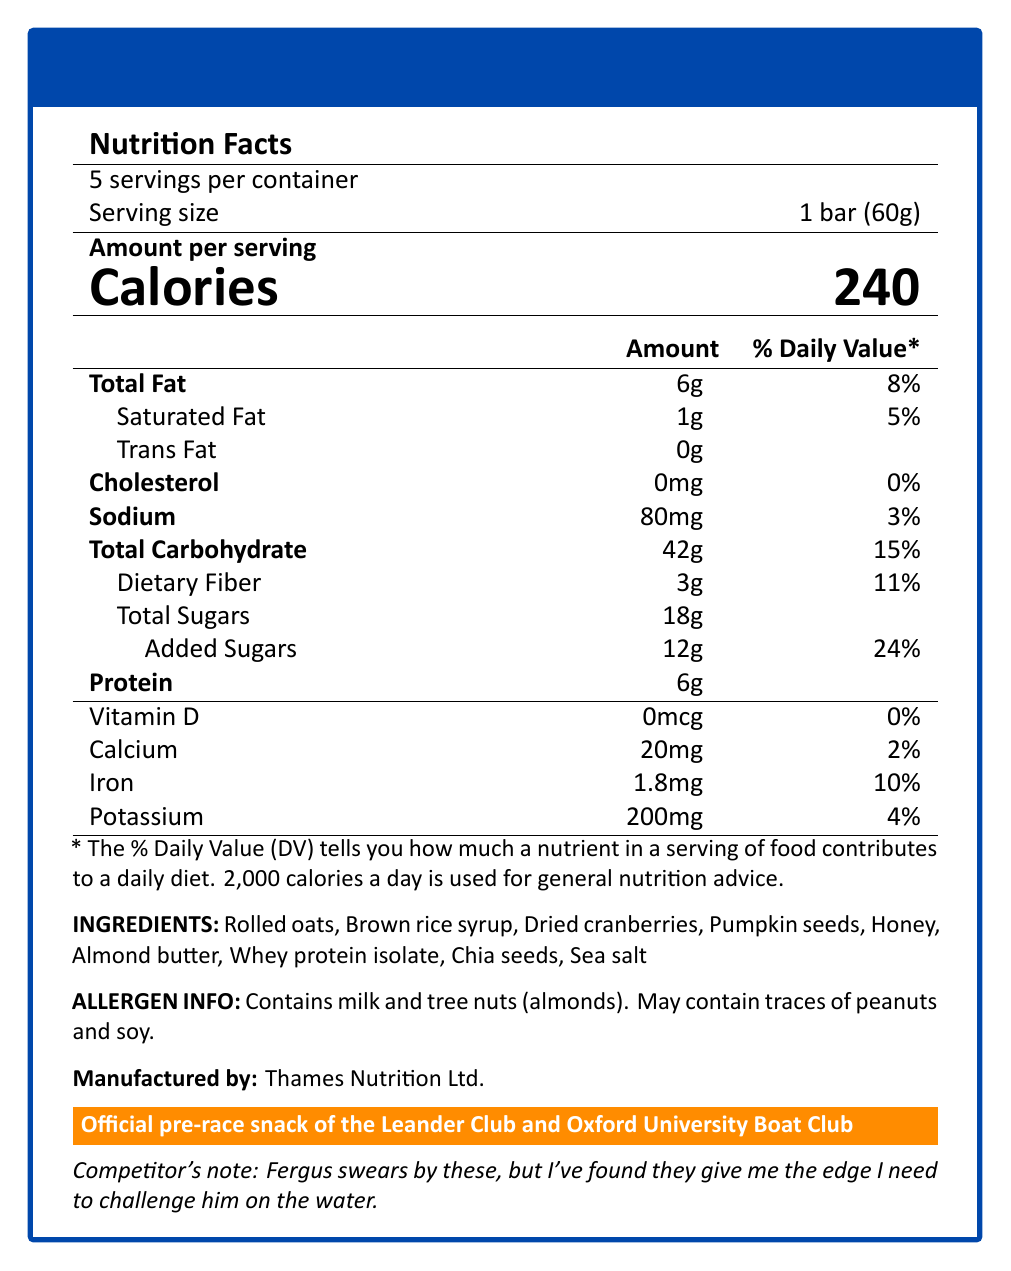what is the serving size? The serving size is clearly stated as "1 bar (60g)" under "Serving size."
Answer: 1 bar (60g) how many servings are there per container? The document mentions that there are 5 servings per container.
Answer: 5 how many total calories are there in one bar? Under "Amount per serving," it lists "Calories" with the value "240."
Answer: 240 what is the primary ingredient in the Power Oar Energy Bar? The ingredients list starts with "Rolled oats."
Answer: Rolled oats what is the total fat content in one serving? Under "Total Fat," the document specifies "6g."
Answer: 6g how much protein does the energy bar contain? The protein content is directly listed as "6g."
Answer: 6g how many grams of added sugars are there per serving? A. 10g B. 12g C. 18g D. 24g The document indicates "Added Sugars" with a value of "12g."
Answer: B. 12g which of the following is a potential allergen in this product? A. Soy B. Peanuts C. Almonds D. All of the above The allergen information mentions it contains milk and tree nuts (almonds) and may contain traces of peanuts and soy. Therefore, D is the correct option.
Answer: D. All of the above are there any trans fats in the Power Oar Energy Bar? The document lists "0g" of trans fat, indicating there are none.
Answer: No does this energy bar contain any Vitamin D? The nutrition information states "0mcg" for Vitamin D, which means it does not contain any Vitamin D.
Answer: No summarize the main purpose of this document. The document's main purpose is to inform consumers about the nutritional characteristics, ingredients, and endorsements of the Power Oar Energy Bar.
Answer: The document provides nutritional information, ingredients, allergen info, and product endorsement for the "Power Oar Energy Bar," a high-carb energy bar designed for British rowers and backed by notable rowing clubs. who manufactures this energy bar? The document specifies that the manufacturer is "Thames Nutrition Ltd."
Answer: Thames Nutrition Ltd. how much sodium is there in one bar? The document lists "Sodium" with a value of "80mg."
Answer: 80mg what is the official pre-race snack of the Leander Club and Oxford University Boat Club? The endorsement section explicitly states that this energy bar is the official pre-race snack of these rowing clubs.
Answer: Power Oar Energy Bar how many grams of dietary fiber are there per serving? Under "Dietary Fiber," the document lists "3g."
Answer: 3g what is the recommended daily value percentage of iron in one serving? The document provides "Iron" with a daily value of "10%."
Answer: 10% what is the calorie content for the entire container? With 5 servings per container and each serving containing 240 calories, the total calorie content for the entire container is 5 * 240 = 1200 calories.
Answer: 1200 calories how much calcium does one serving provide? The document lists "Calcium" with an amount of "20mg."
Answer: 20mg how much honey does this product contain? The document lists honey as an ingredient but doesn't specify the amount.
Answer: Not enough information 